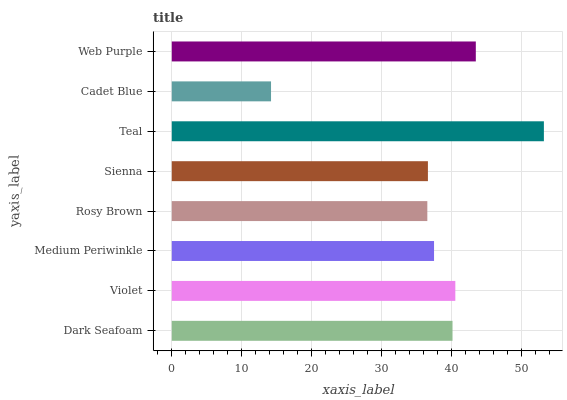Is Cadet Blue the minimum?
Answer yes or no. Yes. Is Teal the maximum?
Answer yes or no. Yes. Is Violet the minimum?
Answer yes or no. No. Is Violet the maximum?
Answer yes or no. No. Is Violet greater than Dark Seafoam?
Answer yes or no. Yes. Is Dark Seafoam less than Violet?
Answer yes or no. Yes. Is Dark Seafoam greater than Violet?
Answer yes or no. No. Is Violet less than Dark Seafoam?
Answer yes or no. No. Is Dark Seafoam the high median?
Answer yes or no. Yes. Is Medium Periwinkle the low median?
Answer yes or no. Yes. Is Rosy Brown the high median?
Answer yes or no. No. Is Web Purple the low median?
Answer yes or no. No. 